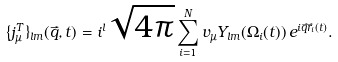<formula> <loc_0><loc_0><loc_500><loc_500>\{ j ^ { T } _ { \mu } \} _ { l m } ( \vec { q } , t ) = i ^ { l } \sqrt { 4 \pi } \sum _ { i = 1 } ^ { N } v _ { \mu } Y _ { l m } ( \Omega _ { i } ( t ) ) \, e ^ { i \vec { q } \vec { r } _ { i } ( t ) } .</formula> 